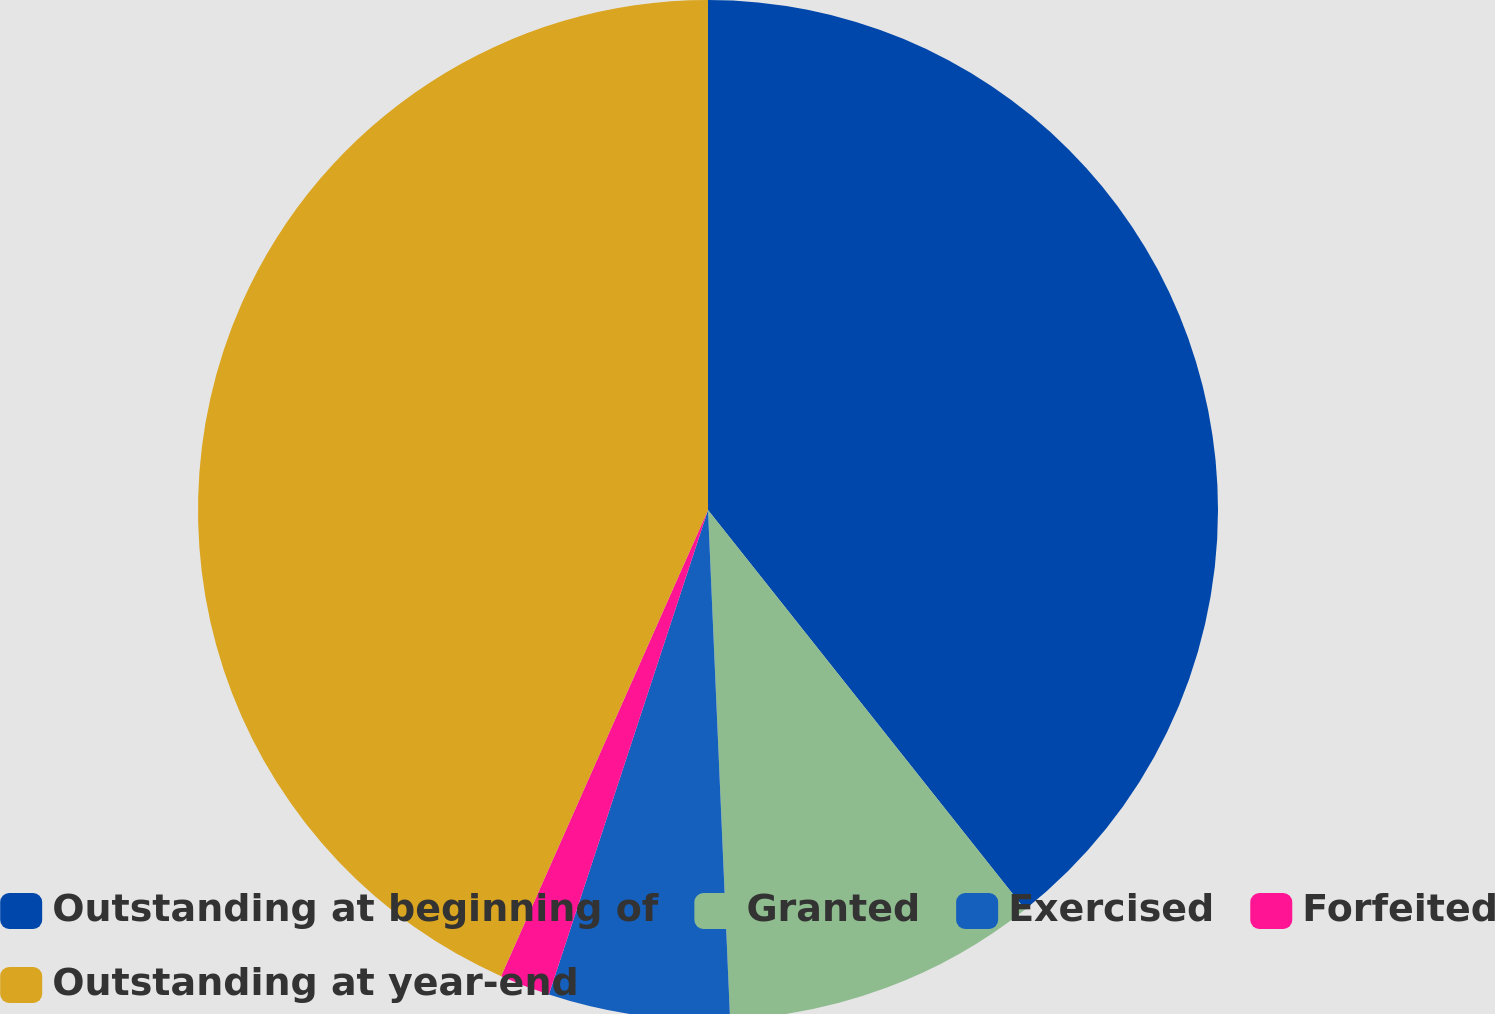Convert chart. <chart><loc_0><loc_0><loc_500><loc_500><pie_chart><fcel>Outstanding at beginning of<fcel>Granted<fcel>Exercised<fcel>Forfeited<fcel>Outstanding at year-end<nl><fcel>39.32%<fcel>9.99%<fcel>5.74%<fcel>1.6%<fcel>43.35%<nl></chart> 